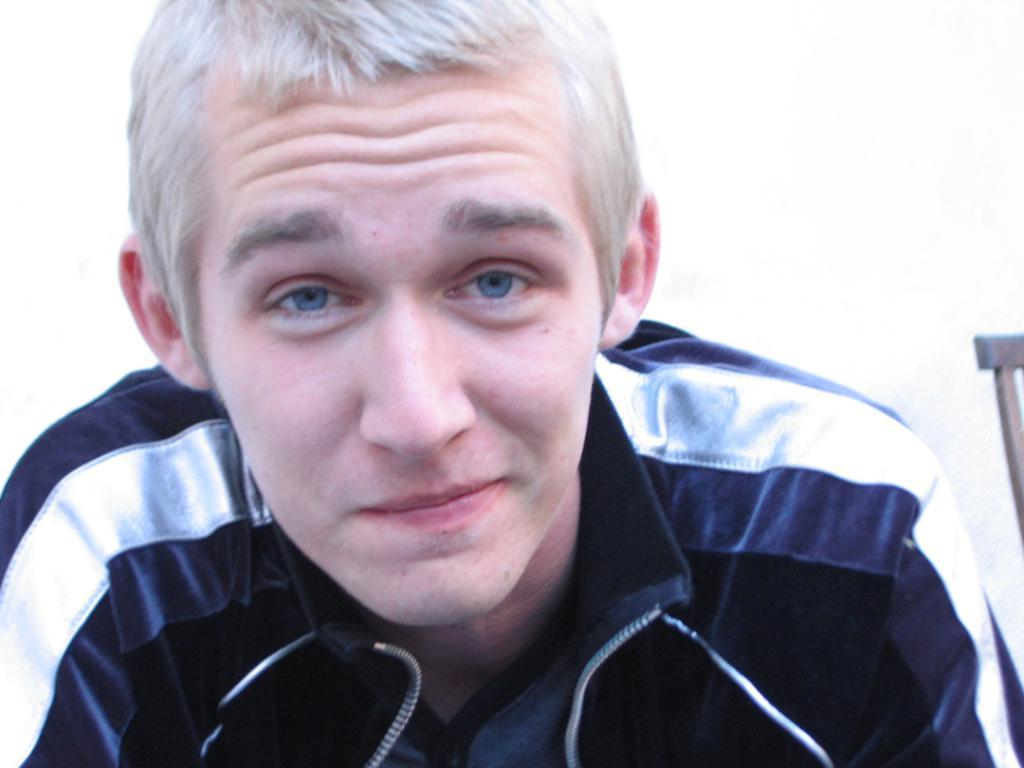What is the main subject of the image? There is a man in the image. How many dogs are visible in the image? There are no dogs present in the image; it features a man. What type of snake can be seen wrapped around the man's neck in the image? There is no snake present in the image; it only features a man. 